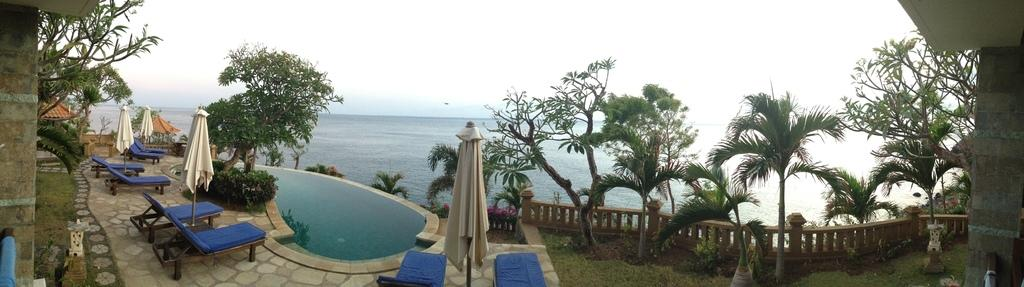What is one of the natural elements visible in the image? Water is visible in the image. What type of furniture is present in the image? There are rest-chairs in the image. What type of vegetation can be seen in the image? Grass, plants, and trees are visible in the image. What is visible in the background of the image? The sky is visible in the image. What type of wool is being used to create the clouds in the image? There is no wool present in the image, and the clouds are not created by any material. Can you tell me how many eggs are hidden in the grass in the image? There are no eggs present in the image; it features grass, plants, trees, and other natural elements. 